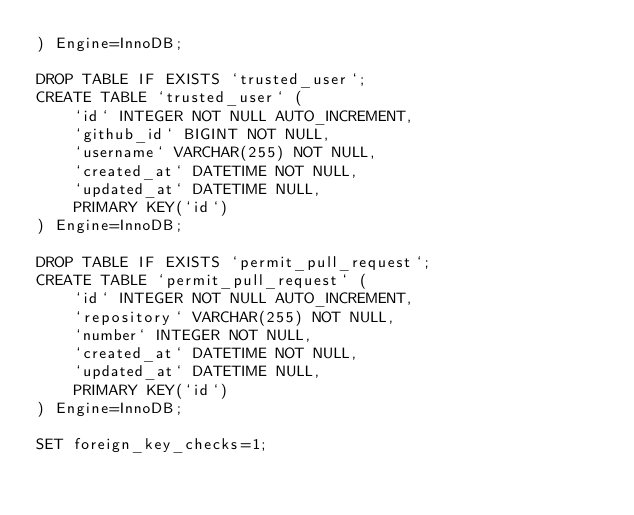Convert code to text. <code><loc_0><loc_0><loc_500><loc_500><_SQL_>) Engine=InnoDB;

DROP TABLE IF EXISTS `trusted_user`;
CREATE TABLE `trusted_user` (
	`id` INTEGER NOT NULL AUTO_INCREMENT,
	`github_id` BIGINT NOT NULL,
	`username` VARCHAR(255) NOT NULL,
	`created_at` DATETIME NOT NULL,
	`updated_at` DATETIME NULL,
	PRIMARY KEY(`id`)
) Engine=InnoDB;

DROP TABLE IF EXISTS `permit_pull_request`;
CREATE TABLE `permit_pull_request` (
	`id` INTEGER NOT NULL AUTO_INCREMENT,
	`repository` VARCHAR(255) NOT NULL,
	`number` INTEGER NOT NULL,
	`created_at` DATETIME NOT NULL,
	`updated_at` DATETIME NULL,
	PRIMARY KEY(`id`)
) Engine=InnoDB;

SET foreign_key_checks=1;
</code> 